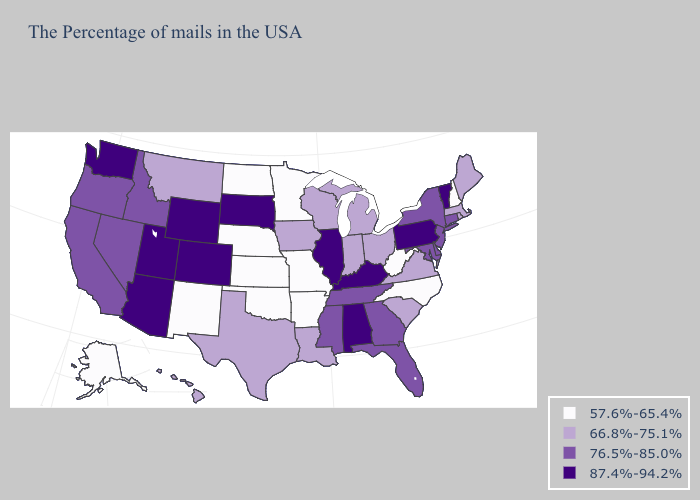Among the states that border Colorado , does Wyoming have the highest value?
Answer briefly. Yes. Name the states that have a value in the range 87.4%-94.2%?
Answer briefly. Vermont, Pennsylvania, Kentucky, Alabama, Illinois, South Dakota, Wyoming, Colorado, Utah, Arizona, Washington. Name the states that have a value in the range 87.4%-94.2%?
Quick response, please. Vermont, Pennsylvania, Kentucky, Alabama, Illinois, South Dakota, Wyoming, Colorado, Utah, Arizona, Washington. What is the value of Montana?
Be succinct. 66.8%-75.1%. Name the states that have a value in the range 76.5%-85.0%?
Short answer required. Connecticut, New York, New Jersey, Delaware, Maryland, Florida, Georgia, Tennessee, Mississippi, Idaho, Nevada, California, Oregon. Which states have the lowest value in the USA?
Write a very short answer. New Hampshire, North Carolina, West Virginia, Missouri, Arkansas, Minnesota, Kansas, Nebraska, Oklahoma, North Dakota, New Mexico, Alaska. Among the states that border Ohio , does West Virginia have the lowest value?
Short answer required. Yes. Name the states that have a value in the range 57.6%-65.4%?
Give a very brief answer. New Hampshire, North Carolina, West Virginia, Missouri, Arkansas, Minnesota, Kansas, Nebraska, Oklahoma, North Dakota, New Mexico, Alaska. What is the value of Arkansas?
Be succinct. 57.6%-65.4%. What is the value of Hawaii?
Write a very short answer. 66.8%-75.1%. Among the states that border Michigan , which have the highest value?
Quick response, please. Ohio, Indiana, Wisconsin. Among the states that border Pennsylvania , which have the highest value?
Write a very short answer. New York, New Jersey, Delaware, Maryland. Among the states that border Connecticut , which have the highest value?
Write a very short answer. New York. Among the states that border Maine , which have the lowest value?
Answer briefly. New Hampshire. What is the value of Oklahoma?
Write a very short answer. 57.6%-65.4%. 